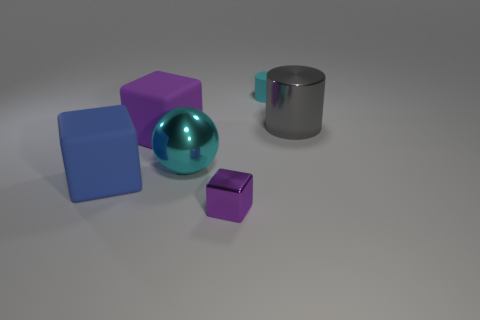What material is the big thing that is on the left side of the purple matte thing?
Offer a terse response. Rubber. How many things are either cubes left of the tiny shiny object or small cyan cylinders?
Your answer should be compact. 3. How many other things are the same shape as the large cyan metallic thing?
Give a very brief answer. 0. There is a big thing that is on the left side of the large purple matte thing; does it have the same shape as the large purple object?
Offer a very short reply. Yes. There is a big cyan shiny sphere; are there any purple matte objects on the left side of it?
Provide a short and direct response. Yes. How many big things are blue metal balls or blue objects?
Offer a very short reply. 1. Is the blue cube made of the same material as the tiny cyan thing?
Make the answer very short. Yes. The sphere that is the same color as the tiny rubber cylinder is what size?
Your response must be concise. Large. Are there any tiny cylinders of the same color as the small rubber object?
Your response must be concise. No. There is another block that is the same material as the blue block; what is its size?
Make the answer very short. Large. 